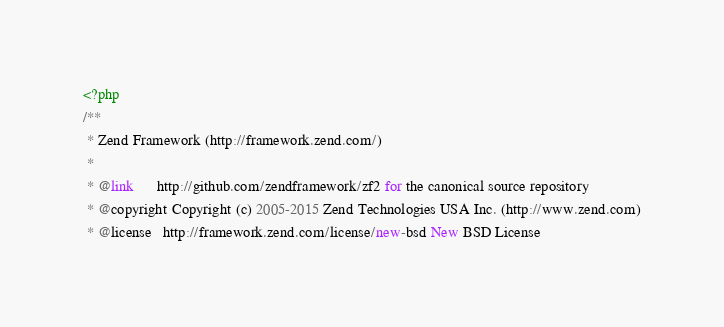Convert code to text. <code><loc_0><loc_0><loc_500><loc_500><_PHP_><?php
/**
 * Zend Framework (http://framework.zend.com/)
 *
 * @link      http://github.com/zendframework/zf2 for the canonical source repository
 * @copyright Copyright (c) 2005-2015 Zend Technologies USA Inc. (http://www.zend.com)
 * @license   http://framework.zend.com/license/new-bsd New BSD License</code> 